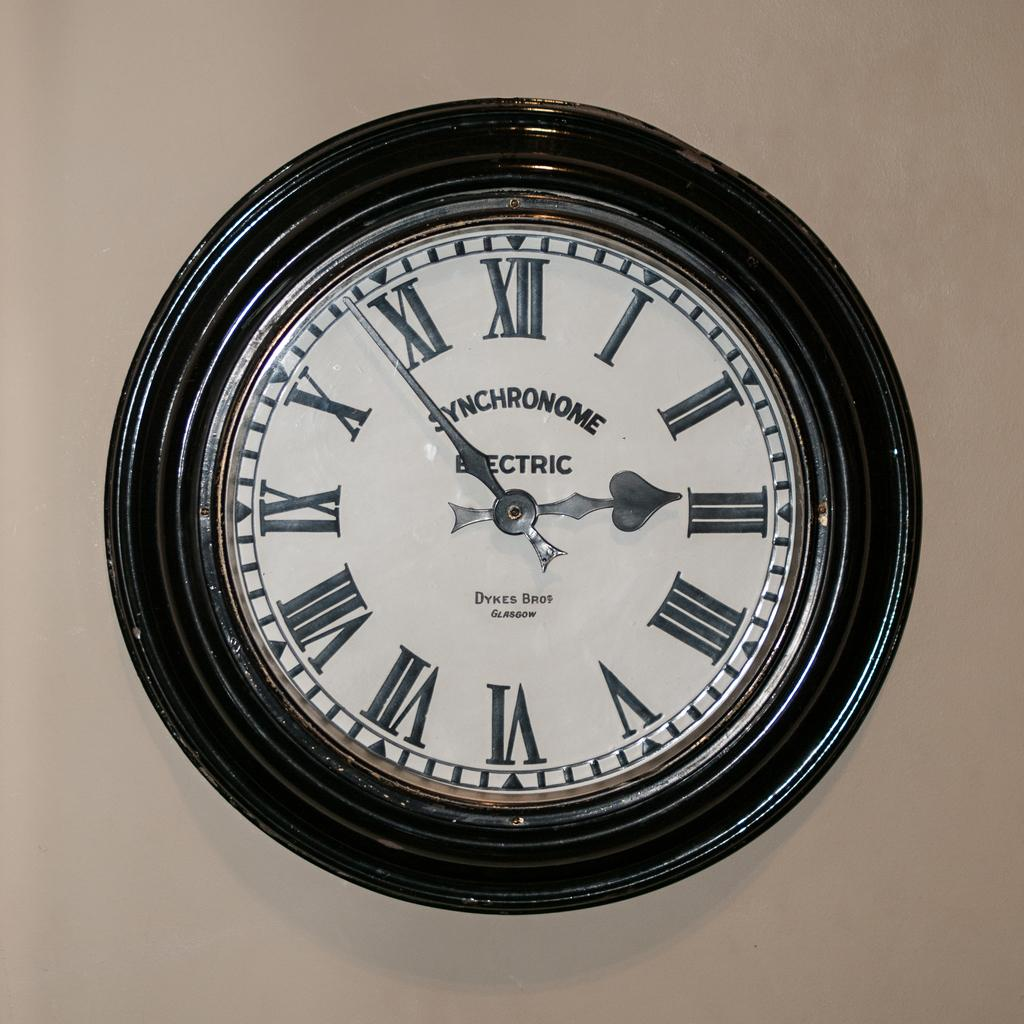<image>
Render a clear and concise summary of the photo. A wall clock with roman numerals indicating that the time is 2:49. 